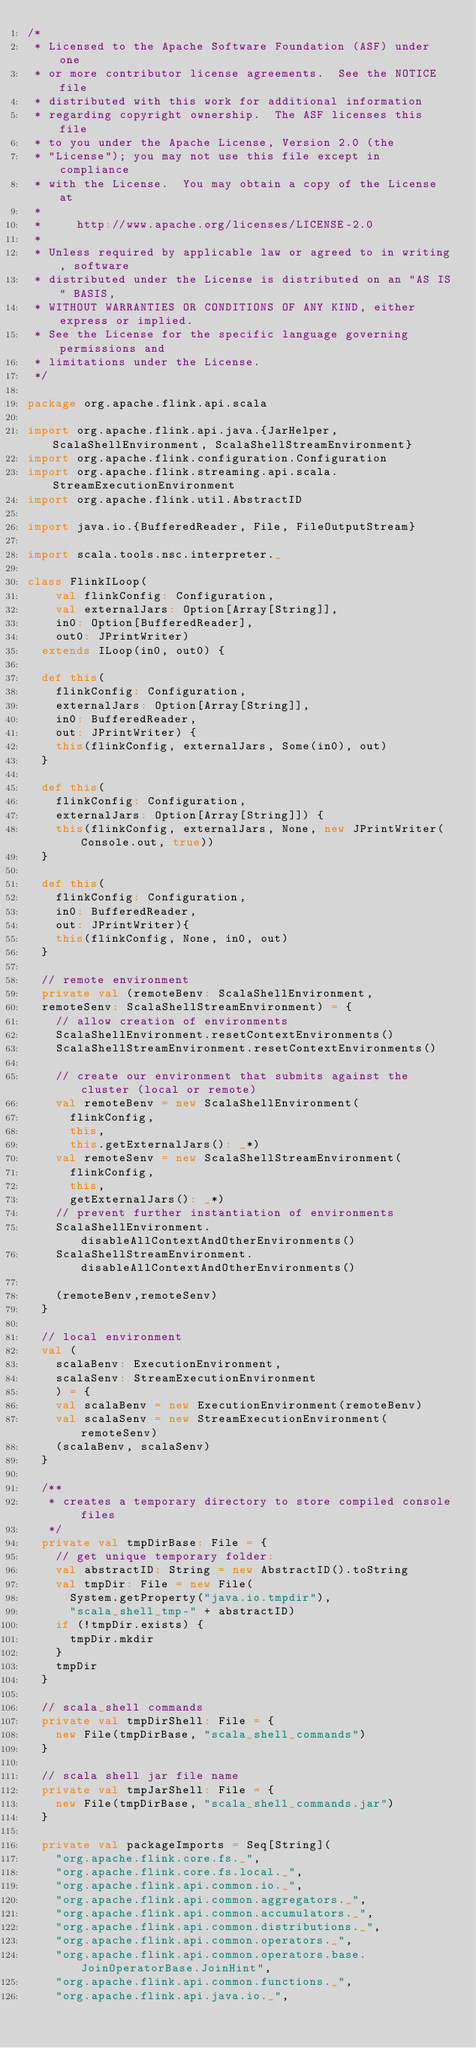Convert code to text. <code><loc_0><loc_0><loc_500><loc_500><_Scala_>/*
 * Licensed to the Apache Software Foundation (ASF) under one
 * or more contributor license agreements.  See the NOTICE file
 * distributed with this work for additional information
 * regarding copyright ownership.  The ASF licenses this file
 * to you under the Apache License, Version 2.0 (the
 * "License"); you may not use this file except in compliance
 * with the License.  You may obtain a copy of the License at
 *
 *     http://www.apache.org/licenses/LICENSE-2.0
 *
 * Unless required by applicable law or agreed to in writing, software
 * distributed under the License is distributed on an "AS IS" BASIS,
 * WITHOUT WARRANTIES OR CONDITIONS OF ANY KIND, either express or implied.
 * See the License for the specific language governing permissions and
 * limitations under the License.
 */

package org.apache.flink.api.scala

import org.apache.flink.api.java.{JarHelper, ScalaShellEnvironment, ScalaShellStreamEnvironment}
import org.apache.flink.configuration.Configuration
import org.apache.flink.streaming.api.scala.StreamExecutionEnvironment
import org.apache.flink.util.AbstractID

import java.io.{BufferedReader, File, FileOutputStream}

import scala.tools.nsc.interpreter._

class FlinkILoop(
    val flinkConfig: Configuration,
    val externalJars: Option[Array[String]],
    in0: Option[BufferedReader],
    out0: JPrintWriter)
  extends ILoop(in0, out0) {

  def this(
    flinkConfig: Configuration,
    externalJars: Option[Array[String]],
    in0: BufferedReader,
    out: JPrintWriter) {
    this(flinkConfig, externalJars, Some(in0), out)
  }

  def this(
    flinkConfig: Configuration,
    externalJars: Option[Array[String]]) {
    this(flinkConfig, externalJars, None, new JPrintWriter(Console.out, true))
  }

  def this(
    flinkConfig: Configuration,
    in0: BufferedReader,
    out: JPrintWriter){
    this(flinkConfig, None, in0, out)
  }

  // remote environment
  private val (remoteBenv: ScalaShellEnvironment,
  remoteSenv: ScalaShellStreamEnvironment) = {
    // allow creation of environments
    ScalaShellEnvironment.resetContextEnvironments()
    ScalaShellStreamEnvironment.resetContextEnvironments()

    // create our environment that submits against the cluster (local or remote)
    val remoteBenv = new ScalaShellEnvironment(
      flinkConfig,
      this,
      this.getExternalJars(): _*)
    val remoteSenv = new ScalaShellStreamEnvironment(
      flinkConfig,
      this,
      getExternalJars(): _*)
    // prevent further instantiation of environments
    ScalaShellEnvironment.disableAllContextAndOtherEnvironments()
    ScalaShellStreamEnvironment.disableAllContextAndOtherEnvironments()

    (remoteBenv,remoteSenv)
  }

  // local environment
  val (
    scalaBenv: ExecutionEnvironment,
    scalaSenv: StreamExecutionEnvironment
    ) = {
    val scalaBenv = new ExecutionEnvironment(remoteBenv)
    val scalaSenv = new StreamExecutionEnvironment(remoteSenv)
    (scalaBenv, scalaSenv)
  }

  /**
   * creates a temporary directory to store compiled console files
   */
  private val tmpDirBase: File = {
    // get unique temporary folder:
    val abstractID: String = new AbstractID().toString
    val tmpDir: File = new File(
      System.getProperty("java.io.tmpdir"),
      "scala_shell_tmp-" + abstractID)
    if (!tmpDir.exists) {
      tmpDir.mkdir
    }
    tmpDir
  }

  // scala_shell commands
  private val tmpDirShell: File = {
    new File(tmpDirBase, "scala_shell_commands")
  }

  // scala shell jar file name
  private val tmpJarShell: File = {
    new File(tmpDirBase, "scala_shell_commands.jar")
  }

  private val packageImports = Seq[String](
    "org.apache.flink.core.fs._",
    "org.apache.flink.core.fs.local._",
    "org.apache.flink.api.common.io._",
    "org.apache.flink.api.common.aggregators._",
    "org.apache.flink.api.common.accumulators._",
    "org.apache.flink.api.common.distributions._",
    "org.apache.flink.api.common.operators._",
    "org.apache.flink.api.common.operators.base.JoinOperatorBase.JoinHint",
    "org.apache.flink.api.common.functions._",
    "org.apache.flink.api.java.io._",</code> 